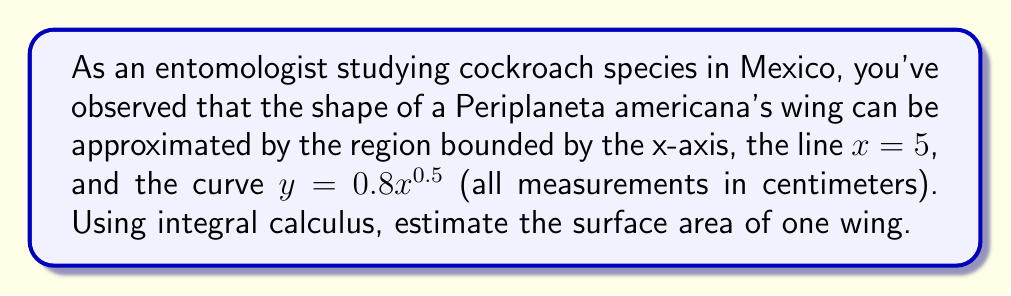Teach me how to tackle this problem. To estimate the surface area of the cockroach wing, we need to calculate the area under the curve $y = 0.8x^{0.5}$ from $x = 0$ to $x = 5$. We can do this using a definite integral:

1) The formula for the area under a curve is:

   $$A = \int_{a}^{b} f(x) dx$$

2) In this case, $f(x) = 0.8x^{0.5}$, $a = 0$, and $b = 5$. So our integral becomes:

   $$A = \int_{0}^{5} 0.8x^{0.5} dx$$

3) To integrate $x^{0.5}$, we use the power rule: $\int x^n dx = \frac{x^{n+1}}{n+1} + C$

   Here, $n = 0.5$, so $n+1 = 1.5$

4) Applying this rule:

   $$A = 0.8 \cdot \frac{x^{1.5}}{1.5} \bigg|_{0}^{5}$$

5) Evaluating the integral:

   $$A = 0.8 \cdot \frac{2}{3} \cdot (5^{1.5} - 0^{1.5})$$
   $$A = \frac{16}{15} \cdot (5^{1.5})$$
   $$A = \frac{16}{15} \cdot 5\sqrt{5}$$

6) Simplifying:

   $$A = \frac{16\sqrt{5}}{3} \approx 11.95 \text{ cm}^2$$

Therefore, the estimated surface area of one wing is approximately 11.95 square centimeters.
Answer: $\frac{16\sqrt{5}}{3} \approx 11.95 \text{ cm}^2$ 